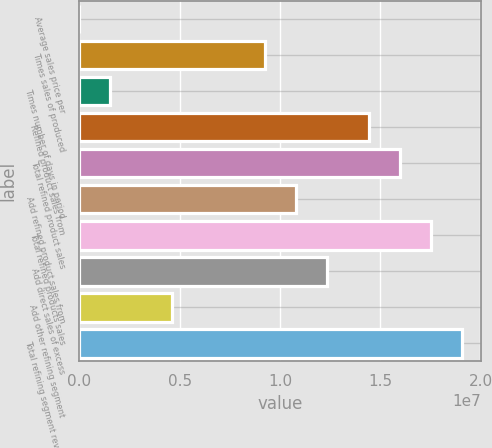Convert chart to OTSL. <chart><loc_0><loc_0><loc_500><loc_500><bar_chart><fcel>Average sales price per<fcel>Times sales of produced<fcel>Times number of days in period<fcel>Refined product sales from<fcel>Total refined product sales<fcel>Add refined product sales from<fcel>Total refined products sales<fcel>Add direct sales of excess<fcel>Add other refining segment<fcel>Total refining segment revenue<nl><fcel>118.82<fcel>9.26376e+06<fcel>1.54406e+06<fcel>1.44298e+07<fcel>1.59738e+07<fcel>1.08077e+07<fcel>1.75177e+07<fcel>1.23516e+07<fcel>4.63194e+06<fcel>1.90617e+07<nl></chart> 